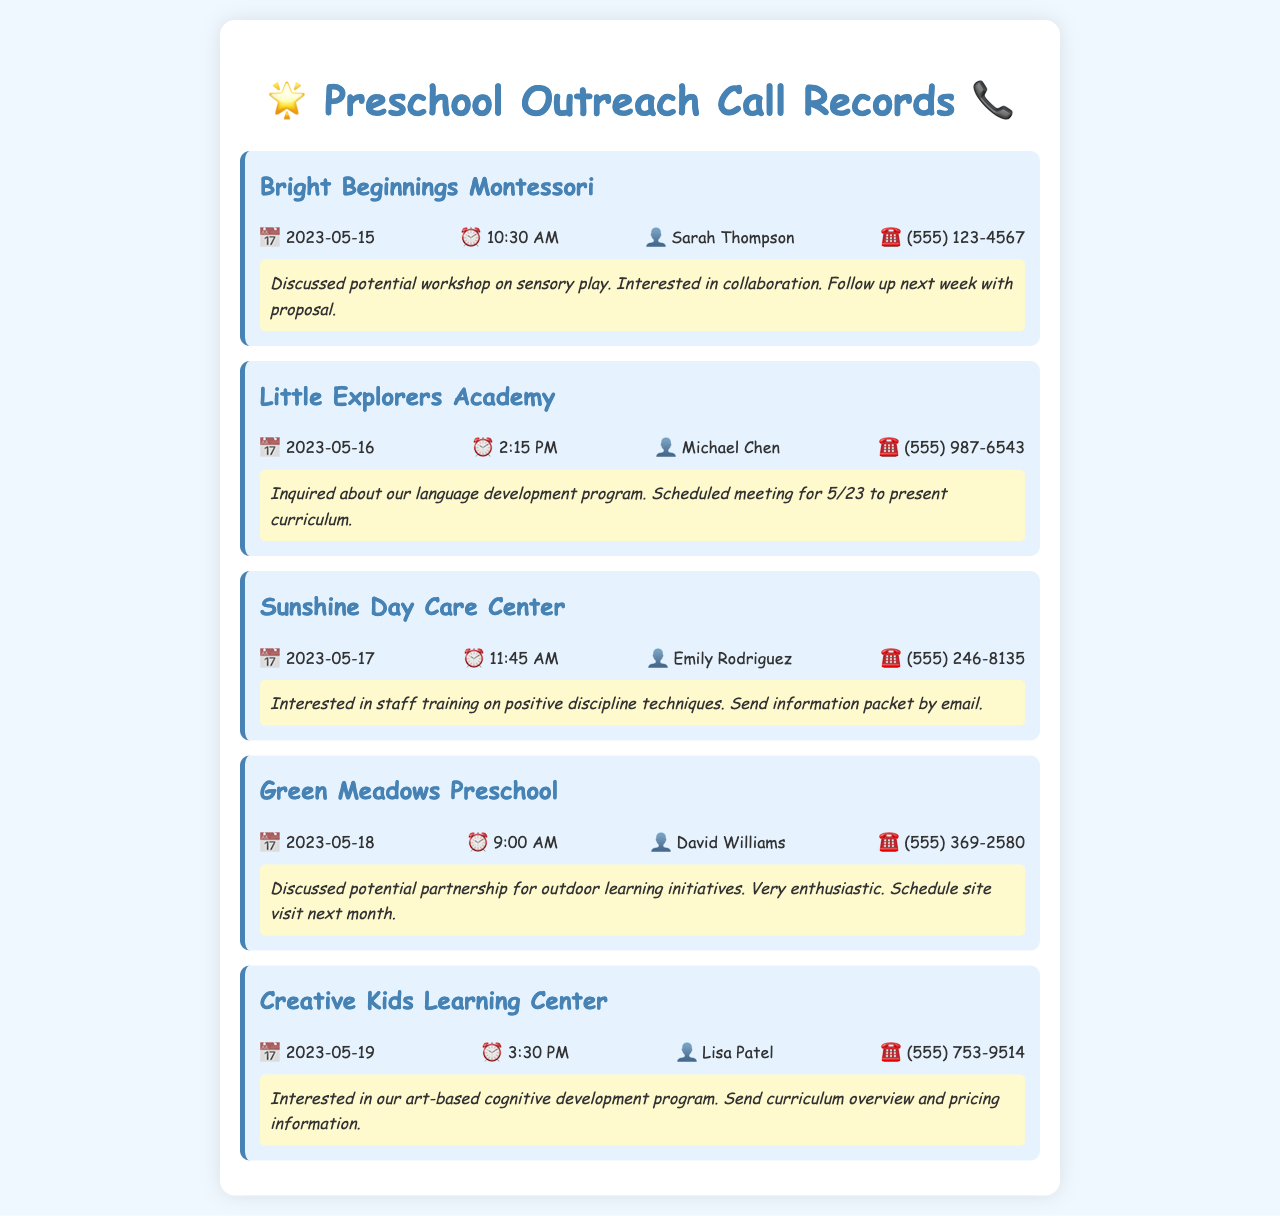What is the date of the call with Bright Beginnings Montessori? The date of the call is mentioned alongside the call details, specifically for Bright Beginnings Montessori on May 15, 2023.
Answer: May 15, 2023 Who did Michael Chen speak with? Michael Chen is the contact person mentioned in the call record for Little Explorers Academy.
Answer: Michael Chen What is the phone number for Sunshine Day Care Center? The phone number is provided in the call record for Sunshine Day Care Center, which is (555) 246-8135.
Answer: (555) 246-8135 What is the main topic discussed with Green Meadows Preschool? The main topic is indicated in the call notes that discuss a potential partnership for outdoor learning initiatives.
Answer: Outdoor learning initiatives When is the scheduled meeting for Little Explorers Academy? The scheduled meeting date is specified in connection with Little Explorers Academy, set for May 23, 2023.
Answer: May 23 Who is interested in staff training? The call record for Sunshine Day Care Center specifies that Emily Rodriguez expressed this interest.
Answer: Emily Rodriguez What type of program does Creative Kids Learning Center inquire about? The call notes indicate that Creative Kids Learning Center is interested in an art-based cognitive development program.
Answer: Art-based cognitive development program How enthusiastic was David Williams about the proposed partnership? The call notes say he was "very enthusiastic" about the proposed partnership.
Answer: Very enthusiastic 